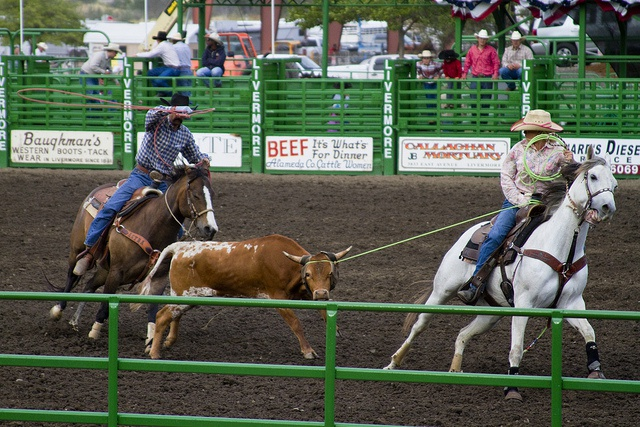Describe the objects in this image and their specific colors. I can see horse in olive, lightgray, darkgray, black, and gray tones, cow in olive, maroon, black, and brown tones, horse in olive, black, maroon, and gray tones, people in olive, lightgray, black, darkgray, and gray tones, and people in olive, black, navy, and gray tones in this image. 